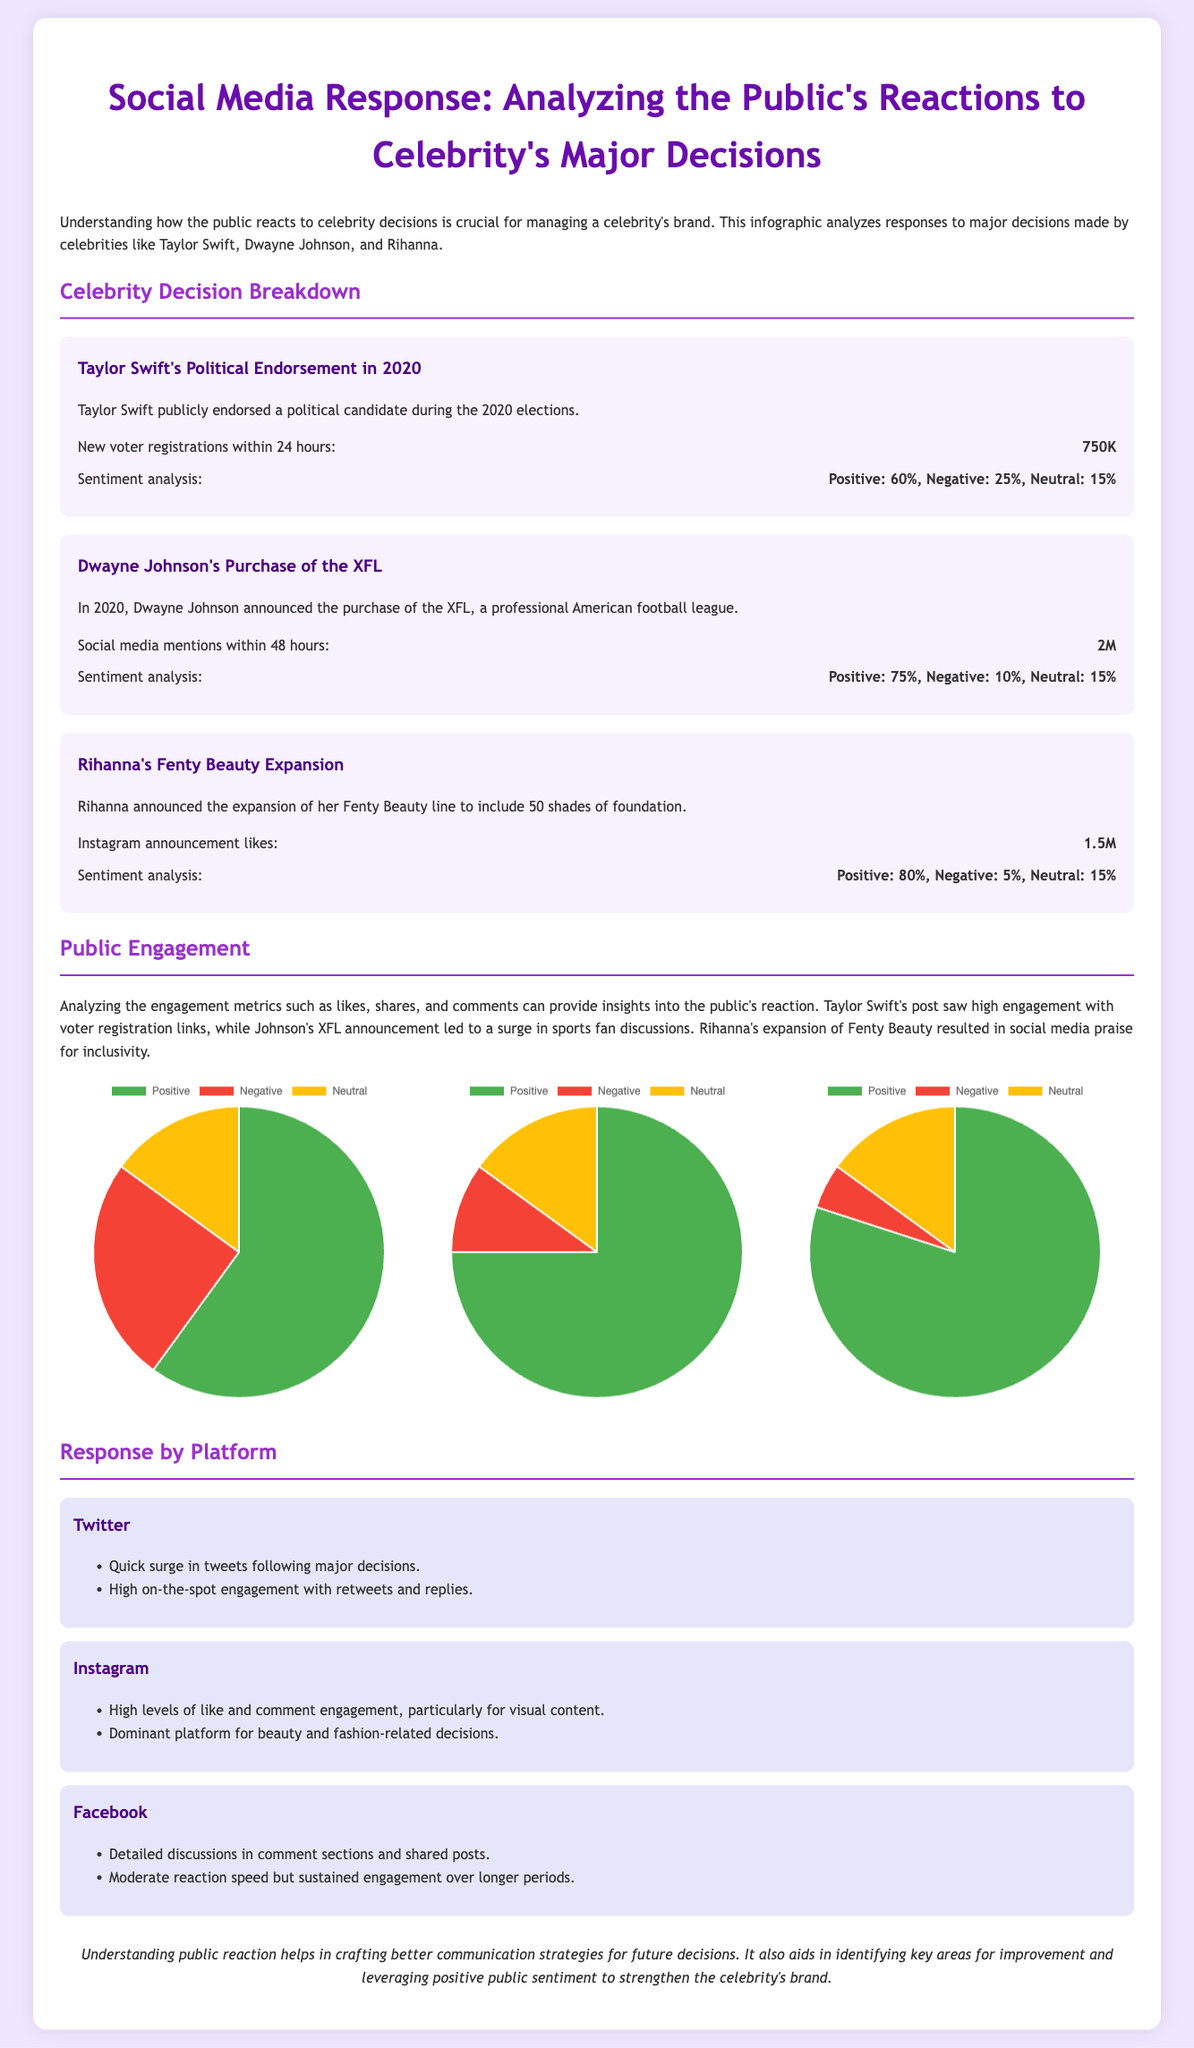what significant action did Taylor Swift take in 2020? Taylor Swift publicly endorsed a political candidate during the 2020 elections.
Answer: political endorsement how many new voter registrations were recorded within 24 hours of Taylor Swift's endorsement? The document states that there were 750,000 new voter registrations following Taylor Swift's endorsement.
Answer: 750K what was the positive sentiment percentage for Dwayne Johnson's XFL purchase? The document specifies that the positive sentiment for Dwayne Johnson's XFL purchase was 75%.
Answer: 75% how many social media mentions did Dwayne Johnson's announcement receive within 48 hours? The announcement received 2 million social media mentions, as indicated in the document.
Answer: 2M which celebrity's expansion announcement received the most positive sentiment? Rihanna had the highest positive sentiment at 80% for her Fenty Beauty expansion.
Answer: 80% what platform is identified as dominant for beauty and fashion-related decisions? The document mentions Instagram as the dominant platform for beauty and fashion-related decisions.
Answer: Instagram what was the sentiment breakdown percentage for Rihanna's Fenty Beauty expansion? The sentiment analysis shows Positive: 80%, Negative: 5%, Neutral: 15%.
Answer: Positive: 80%, Negative: 5%, Neutral: 15% which celebrity's social media engagement mentioned detailed discussions? Facebook is associated with detailed discussions in comments for all celebrities' announcements.
Answer: Facebook what is the conclusion drawn about understanding public reaction? The document concludes that understanding public reaction helps in crafting better communication strategies for future decisions.
Answer: better communication strategies 